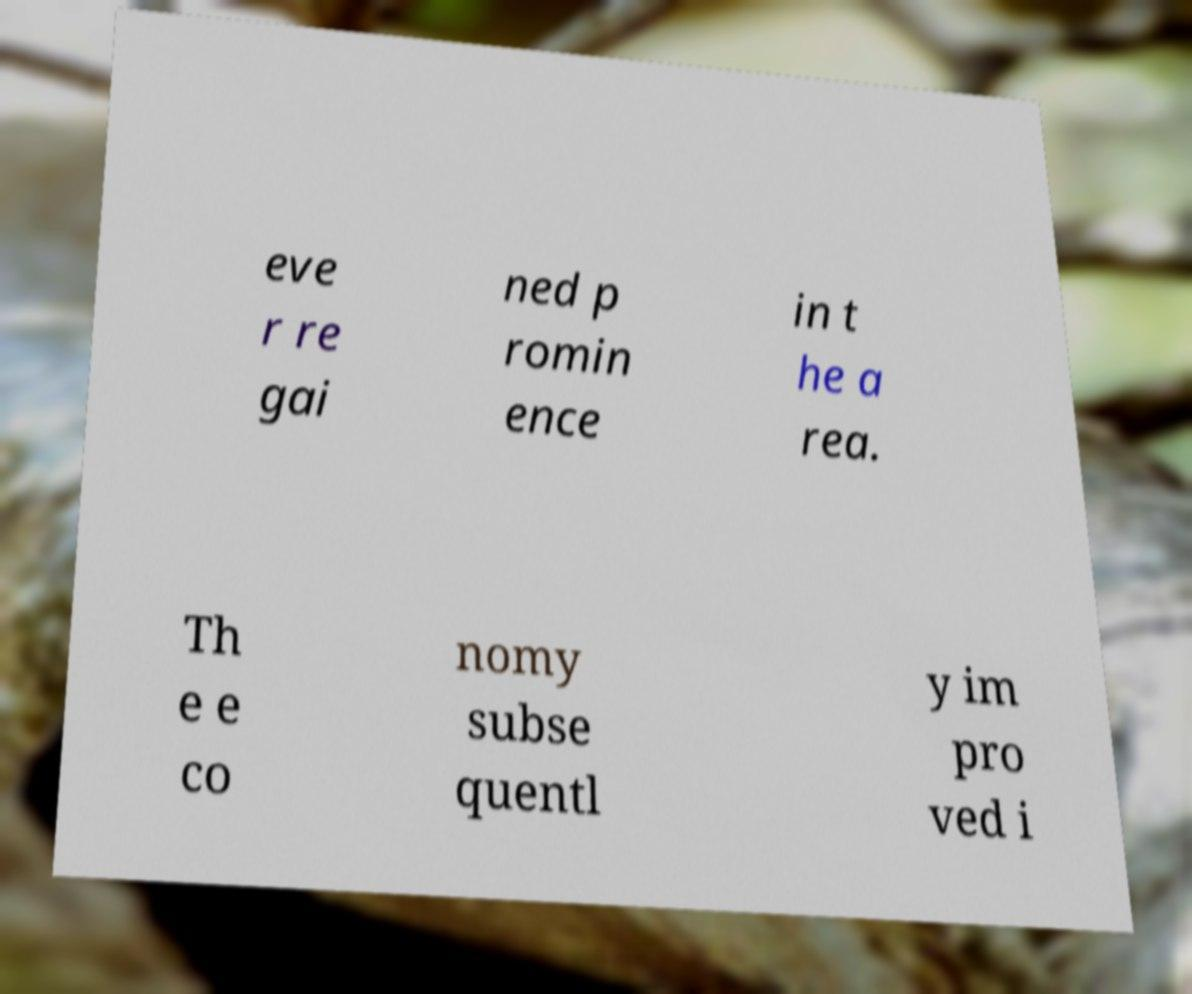I need the written content from this picture converted into text. Can you do that? eve r re gai ned p romin ence in t he a rea. Th e e co nomy subse quentl y im pro ved i 